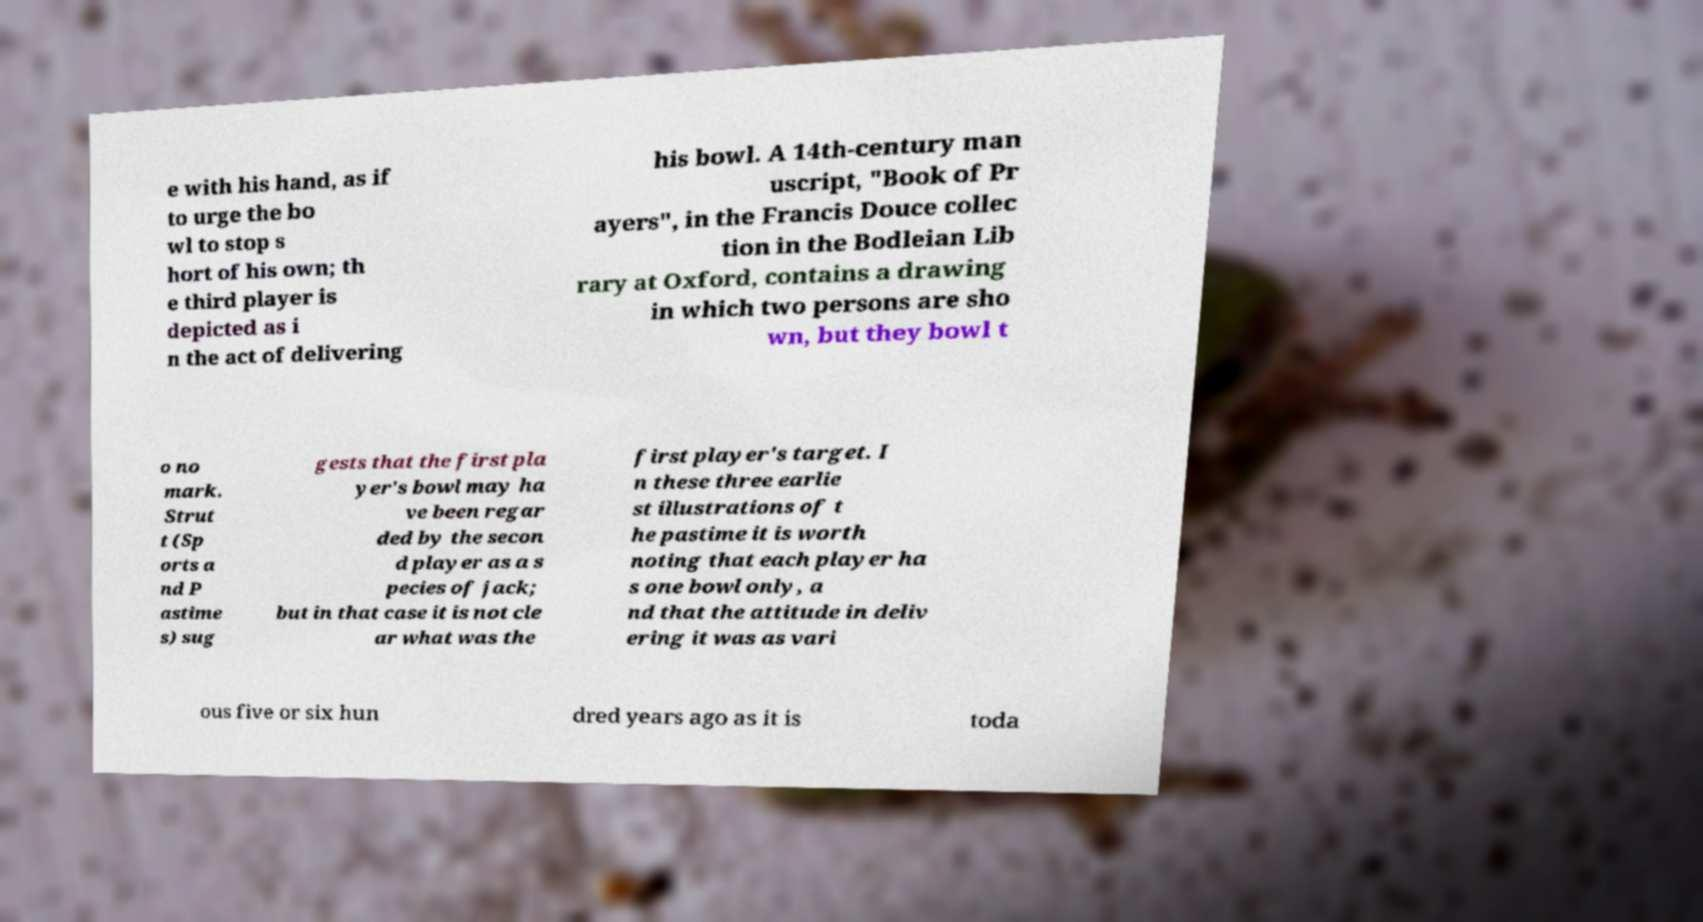Please identify and transcribe the text found in this image. e with his hand, as if to urge the bo wl to stop s hort of his own; th e third player is depicted as i n the act of delivering his bowl. A 14th-century man uscript, "Book of Pr ayers", in the Francis Douce collec tion in the Bodleian Lib rary at Oxford, contains a drawing in which two persons are sho wn, but they bowl t o no mark. Strut t (Sp orts a nd P astime s) sug gests that the first pla yer's bowl may ha ve been regar ded by the secon d player as a s pecies of jack; but in that case it is not cle ar what was the first player's target. I n these three earlie st illustrations of t he pastime it is worth noting that each player ha s one bowl only, a nd that the attitude in deliv ering it was as vari ous five or six hun dred years ago as it is toda 